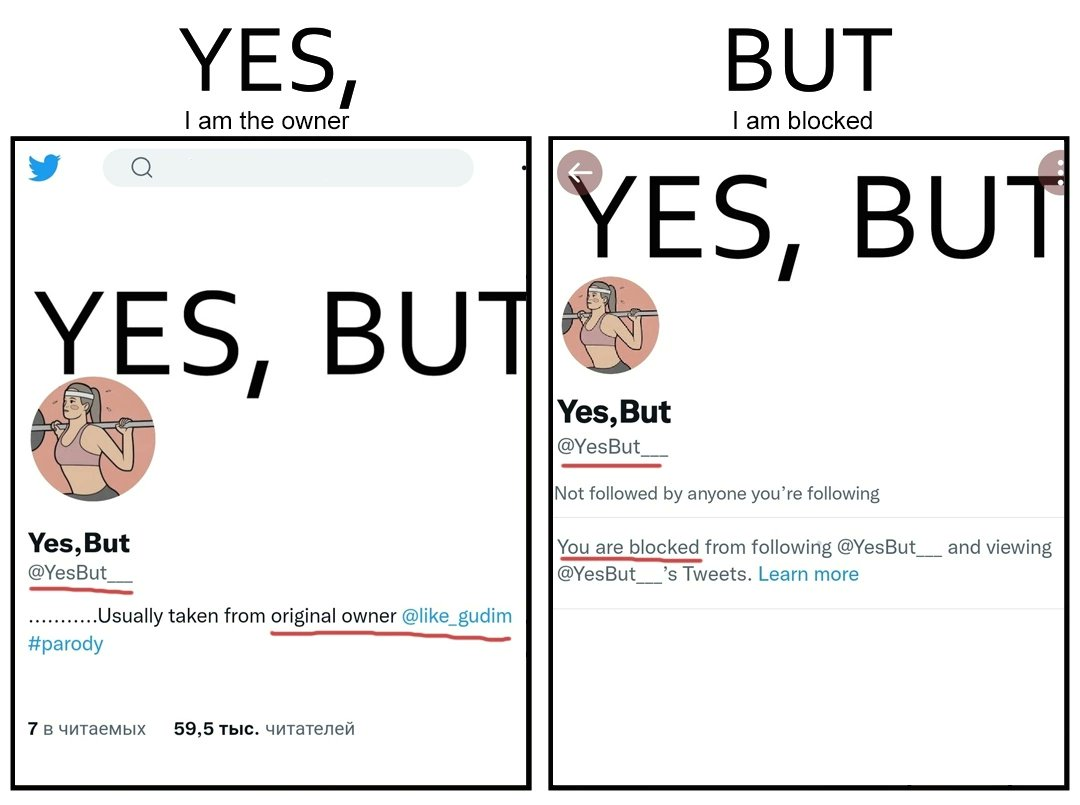Explain the humor or irony in this image. The images are ironic since while the page "Yes, But" credits the original creator "@like_gudim" for its posts, the page "Yes, But" has blocked "@like_gudim" from following the page 